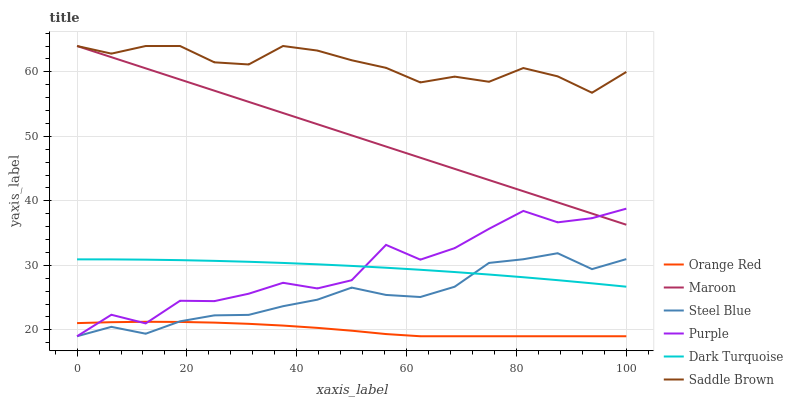Does Orange Red have the minimum area under the curve?
Answer yes or no. Yes. Does Saddle Brown have the maximum area under the curve?
Answer yes or no. Yes. Does Dark Turquoise have the minimum area under the curve?
Answer yes or no. No. Does Dark Turquoise have the maximum area under the curve?
Answer yes or no. No. Is Maroon the smoothest?
Answer yes or no. Yes. Is Purple the roughest?
Answer yes or no. Yes. Is Dark Turquoise the smoothest?
Answer yes or no. No. Is Dark Turquoise the roughest?
Answer yes or no. No. Does Purple have the lowest value?
Answer yes or no. Yes. Does Dark Turquoise have the lowest value?
Answer yes or no. No. Does Saddle Brown have the highest value?
Answer yes or no. Yes. Does Dark Turquoise have the highest value?
Answer yes or no. No. Is Orange Red less than Saddle Brown?
Answer yes or no. Yes. Is Saddle Brown greater than Steel Blue?
Answer yes or no. Yes. Does Dark Turquoise intersect Steel Blue?
Answer yes or no. Yes. Is Dark Turquoise less than Steel Blue?
Answer yes or no. No. Is Dark Turquoise greater than Steel Blue?
Answer yes or no. No. Does Orange Red intersect Saddle Brown?
Answer yes or no. No. 